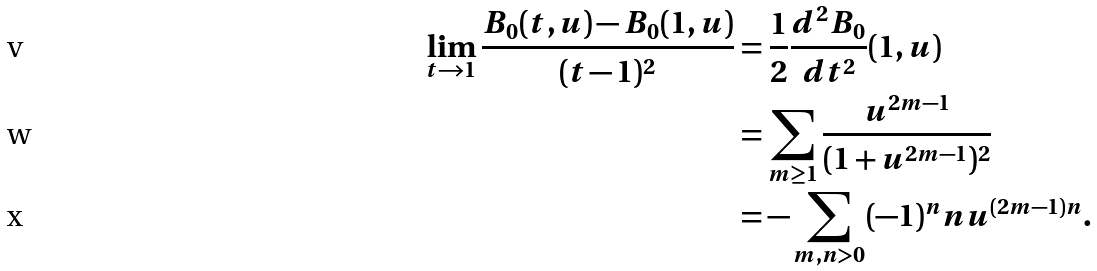Convert formula to latex. <formula><loc_0><loc_0><loc_500><loc_500>\lim _ { t \to 1 } \frac { B _ { 0 } ( t , u ) - B _ { 0 } ( 1 , u ) } { ( t - 1 ) ^ { 2 } } & = \frac { 1 } { 2 } \frac { d ^ { 2 } B _ { 0 } } { d t ^ { 2 } } ( 1 , u ) \\ & = \sum _ { m \geq 1 } \frac { u ^ { 2 m - 1 } } { ( 1 + u ^ { 2 m - 1 } ) ^ { 2 } } \\ & = - \sum _ { m , n > 0 } ( - 1 ) ^ { n } n u ^ { ( 2 m - 1 ) n } .</formula> 